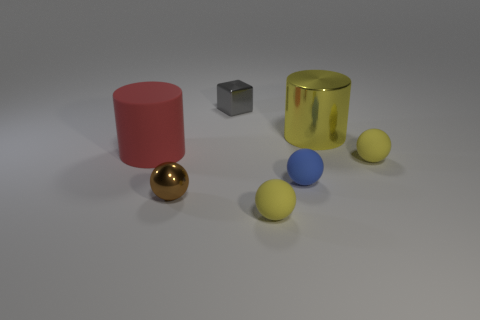There is a yellow rubber thing that is right of the blue matte object; is it the same size as the big metallic thing?
Offer a very short reply. No. What is the size of the yellow metal object that is the same shape as the red rubber object?
Ensure brevity in your answer.  Large. There is another cylinder that is the same size as the red rubber cylinder; what is its material?
Make the answer very short. Metal. What is the material of the small brown thing that is the same shape as the tiny blue matte thing?
Your answer should be compact. Metal. What number of other objects are the same size as the gray thing?
Offer a very short reply. 4. What number of large objects are the same color as the metallic sphere?
Ensure brevity in your answer.  0. What is the shape of the red rubber object?
Provide a short and direct response. Cylinder. What is the color of the tiny object that is both in front of the large yellow metal cylinder and behind the blue thing?
Your answer should be compact. Yellow. What is the material of the small gray object?
Your response must be concise. Metal. There is a tiny yellow object that is to the left of the blue sphere; what shape is it?
Keep it short and to the point. Sphere. 